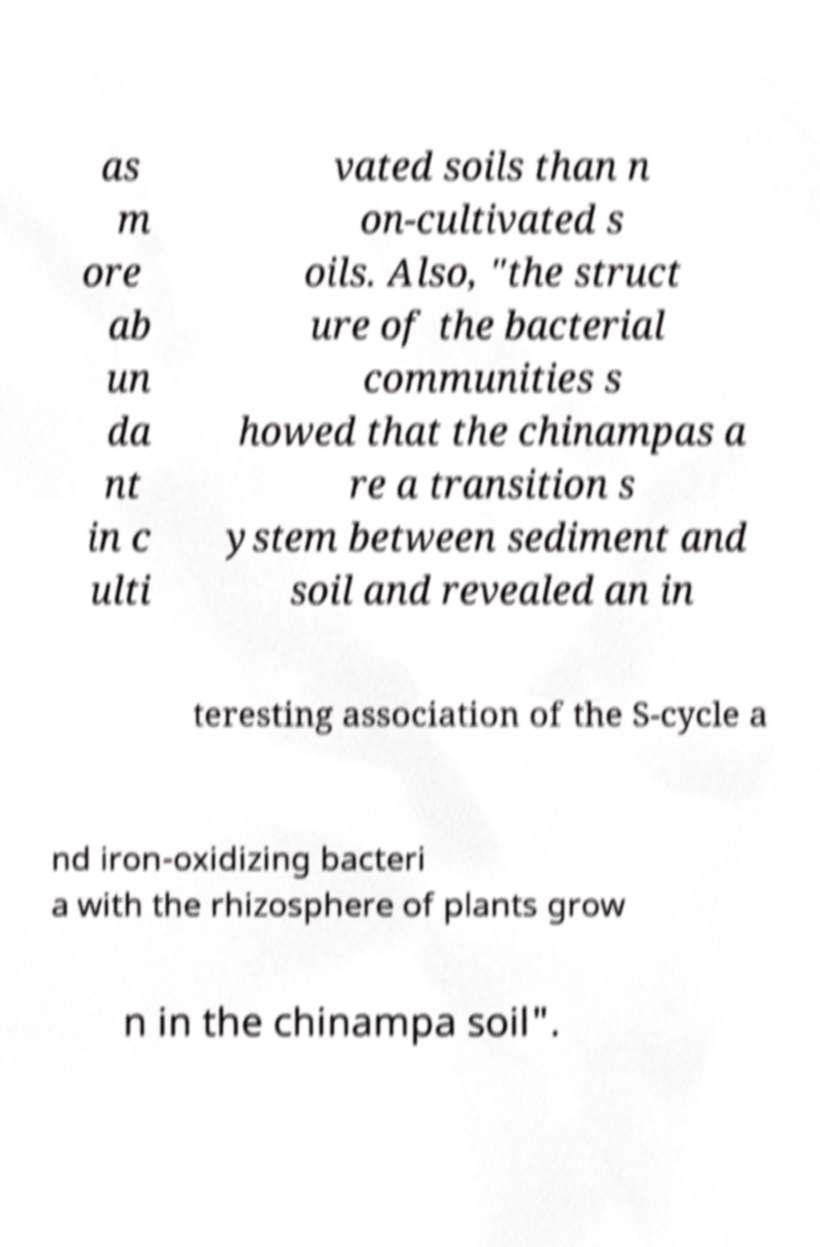Can you read and provide the text displayed in the image?This photo seems to have some interesting text. Can you extract and type it out for me? as m ore ab un da nt in c ulti vated soils than n on-cultivated s oils. Also, "the struct ure of the bacterial communities s howed that the chinampas a re a transition s ystem between sediment and soil and revealed an in teresting association of the S-cycle a nd iron-oxidizing bacteri a with the rhizosphere of plants grow n in the chinampa soil". 